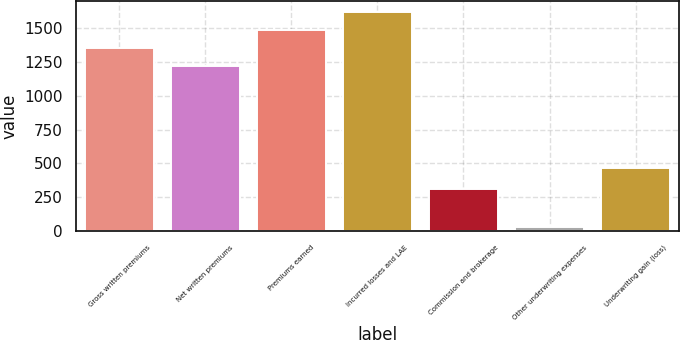Convert chart to OTSL. <chart><loc_0><loc_0><loc_500><loc_500><bar_chart><fcel>Gross written premiums<fcel>Net written premiums<fcel>Premiums earned<fcel>Incurred losses and LAE<fcel>Commission and brokerage<fcel>Other underwriting expenses<fcel>Underwriting gain (loss)<nl><fcel>1353.1<fcel>1218.6<fcel>1487.6<fcel>1622.1<fcel>311<fcel>27.3<fcel>466.1<nl></chart> 